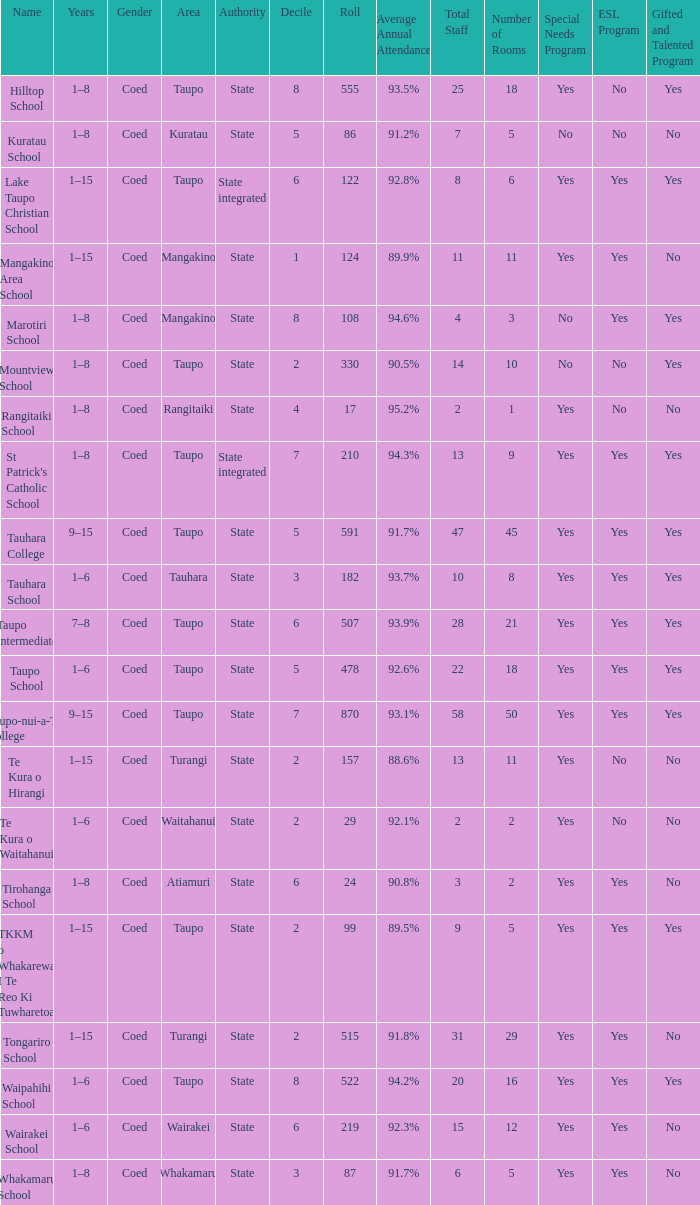What is the Whakamaru school's authority? State. 